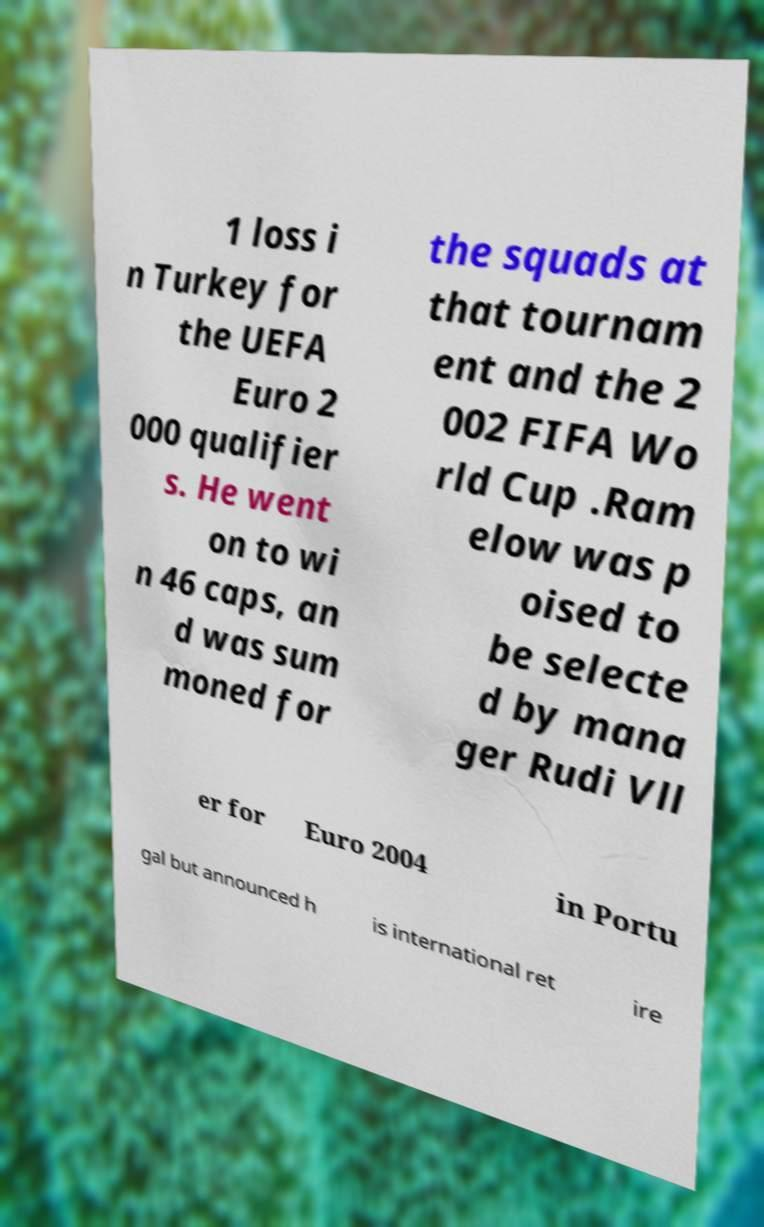Could you assist in decoding the text presented in this image and type it out clearly? 1 loss i n Turkey for the UEFA Euro 2 000 qualifier s. He went on to wi n 46 caps, an d was sum moned for the squads at that tournam ent and the 2 002 FIFA Wo rld Cup .Ram elow was p oised to be selecte d by mana ger Rudi Vll er for Euro 2004 in Portu gal but announced h is international ret ire 